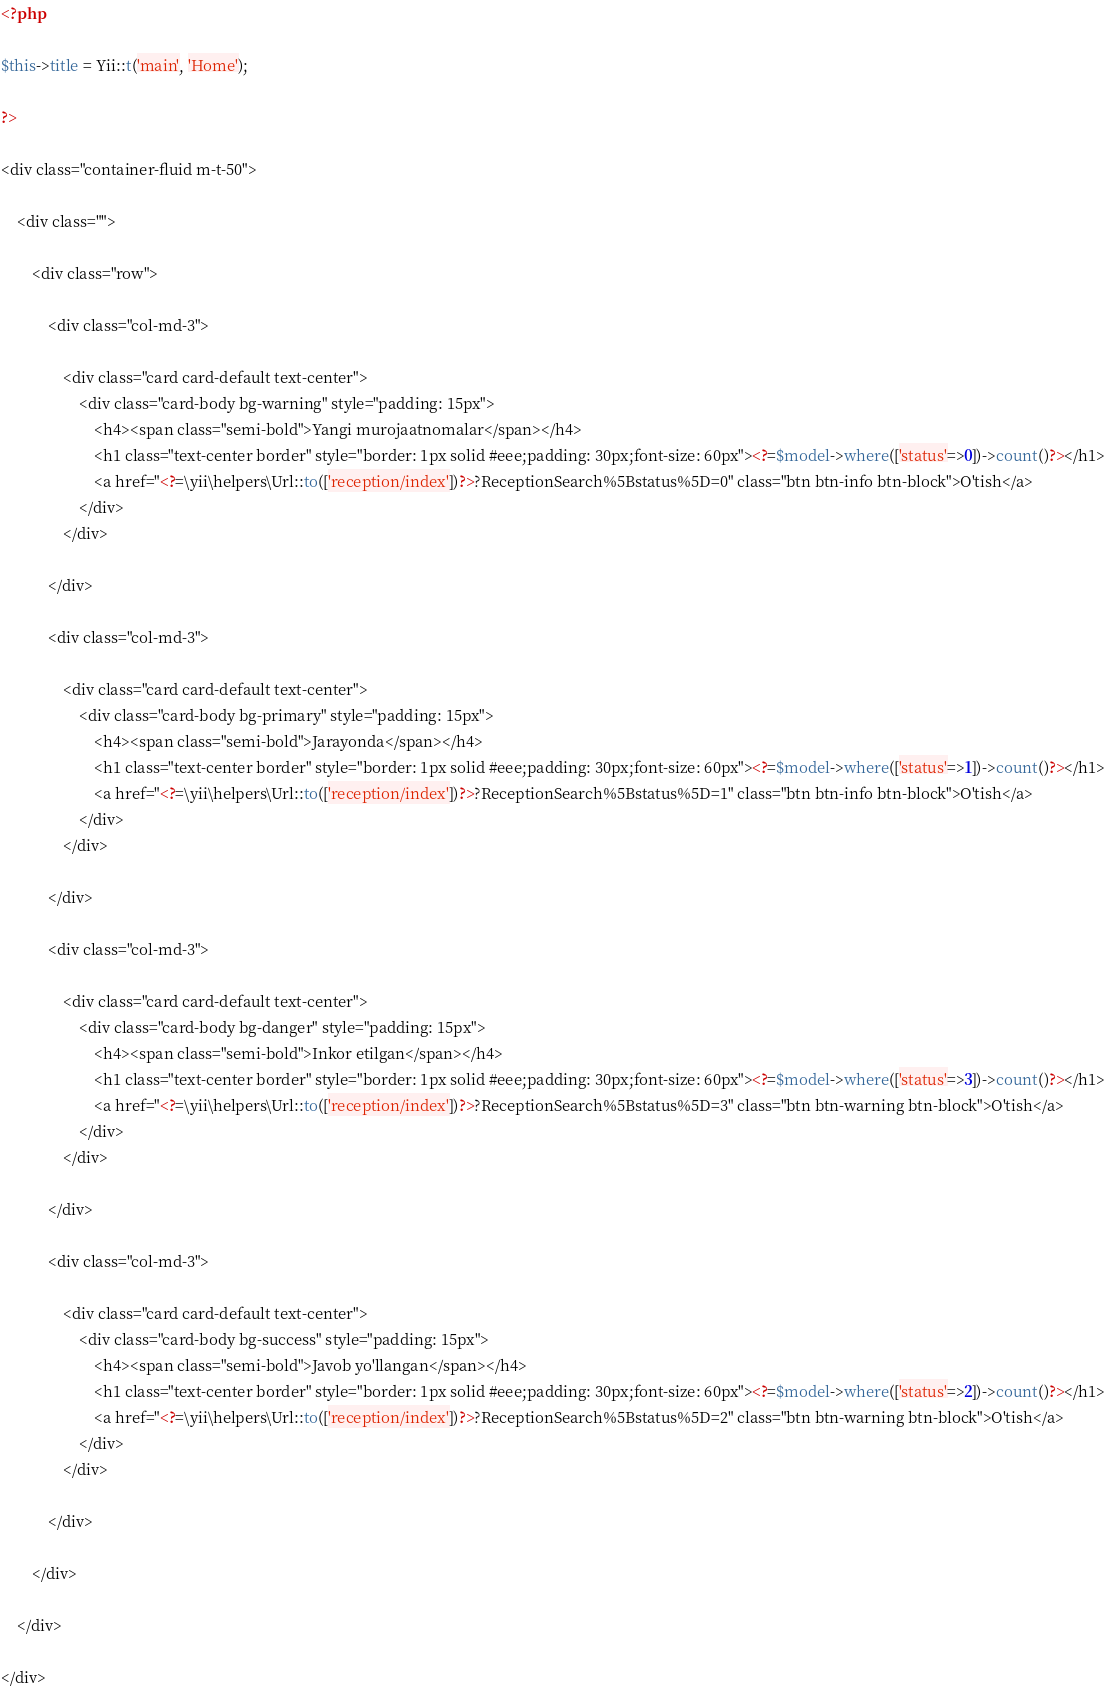Convert code to text. <code><loc_0><loc_0><loc_500><loc_500><_PHP_><?php

$this->title = Yii::t('main', 'Home');

?>

<div class="container-fluid m-t-50">

    <div class="">

        <div class="row">

            <div class="col-md-3">

                <div class="card card-default text-center">
                    <div class="card-body bg-warning" style="padding: 15px">
                        <h4><span class="semi-bold">Yangi murojaatnomalar</span></h4>
                        <h1 class="text-center border" style="border: 1px solid #eee;padding: 30px;font-size: 60px"><?=$model->where(['status'=>0])->count()?></h1>
                        <a href="<?=\yii\helpers\Url::to(['reception/index'])?>?ReceptionSearch%5Bstatus%5D=0" class="btn btn-info btn-block">O'tish</a>
                    </div>
                </div>

            </div>

            <div class="col-md-3">

                <div class="card card-default text-center">
                    <div class="card-body bg-primary" style="padding: 15px">
                        <h4><span class="semi-bold">Jarayonda</span></h4>
                        <h1 class="text-center border" style="border: 1px solid #eee;padding: 30px;font-size: 60px"><?=$model->where(['status'=>1])->count()?></h1>
                        <a href="<?=\yii\helpers\Url::to(['reception/index'])?>?ReceptionSearch%5Bstatus%5D=1" class="btn btn-info btn-block">O'tish</a>
                    </div>
                </div>

            </div>

            <div class="col-md-3">

                <div class="card card-default text-center">
                    <div class="card-body bg-danger" style="padding: 15px">
                        <h4><span class="semi-bold">Inkor etilgan</span></h4>
                        <h1 class="text-center border" style="border: 1px solid #eee;padding: 30px;font-size: 60px"><?=$model->where(['status'=>3])->count()?></h1>
                        <a href="<?=\yii\helpers\Url::to(['reception/index'])?>?ReceptionSearch%5Bstatus%5D=3" class="btn btn-warning btn-block">O'tish</a>
                    </div>
                </div>

            </div>

            <div class="col-md-3">

                <div class="card card-default text-center">
                    <div class="card-body bg-success" style="padding: 15px">
                        <h4><span class="semi-bold">Javob yo'llangan</span></h4>
                        <h1 class="text-center border" style="border: 1px solid #eee;padding: 30px;font-size: 60px"><?=$model->where(['status'=>2])->count()?></h1>
                        <a href="<?=\yii\helpers\Url::to(['reception/index'])?>?ReceptionSearch%5Bstatus%5D=2" class="btn btn-warning btn-block">O'tish</a>
                    </div>
                </div>

            </div>

        </div>

    </div>

</div></code> 